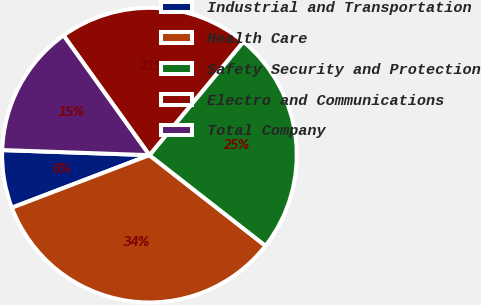Convert chart. <chart><loc_0><loc_0><loc_500><loc_500><pie_chart><fcel>Industrial and Transportation<fcel>Health Care<fcel>Safety Security and Protection<fcel>Electro and Communications<fcel>Total Company<nl><fcel>6.36%<fcel>33.64%<fcel>24.55%<fcel>20.91%<fcel>14.55%<nl></chart> 